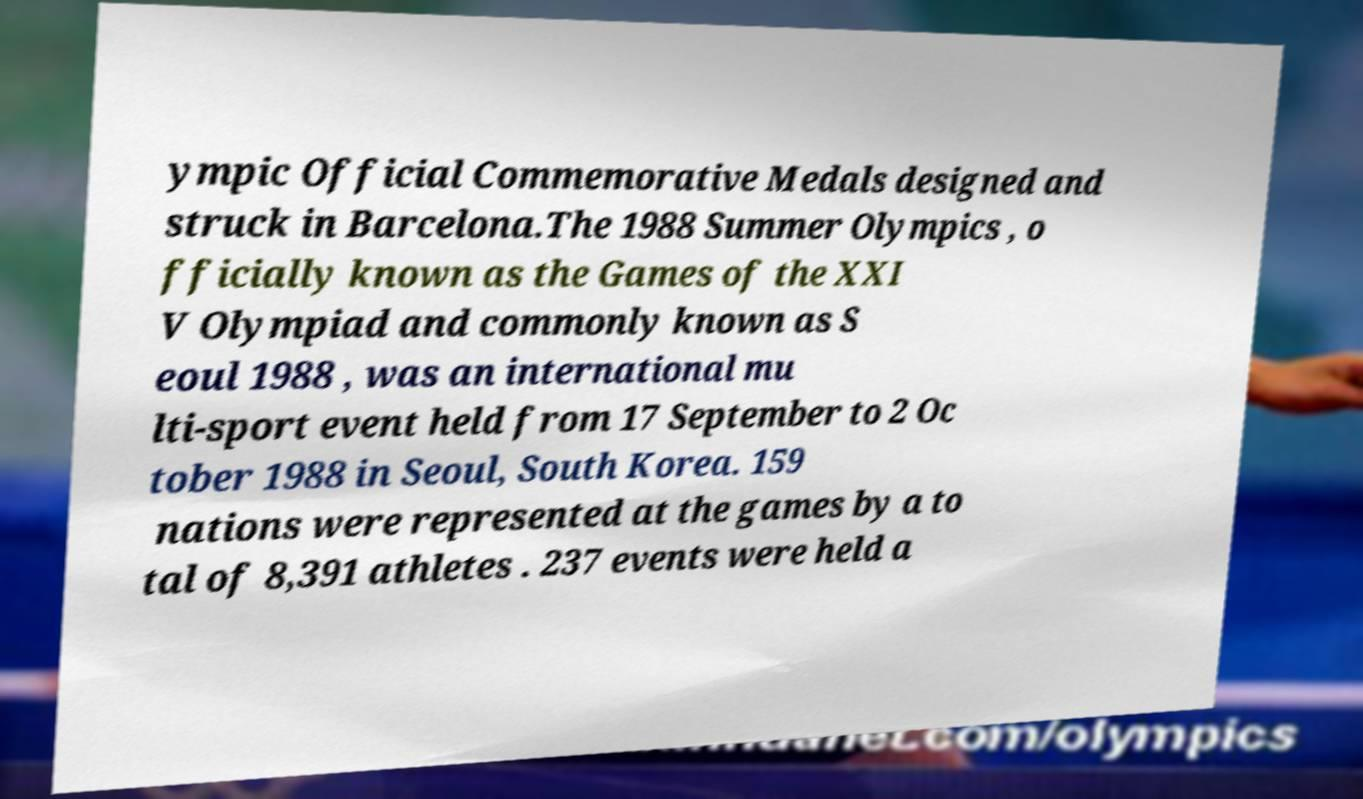Can you read and provide the text displayed in the image?This photo seems to have some interesting text. Can you extract and type it out for me? ympic Official Commemorative Medals designed and struck in Barcelona.The 1988 Summer Olympics , o fficially known as the Games of the XXI V Olympiad and commonly known as S eoul 1988 , was an international mu lti-sport event held from 17 September to 2 Oc tober 1988 in Seoul, South Korea. 159 nations were represented at the games by a to tal of 8,391 athletes . 237 events were held a 